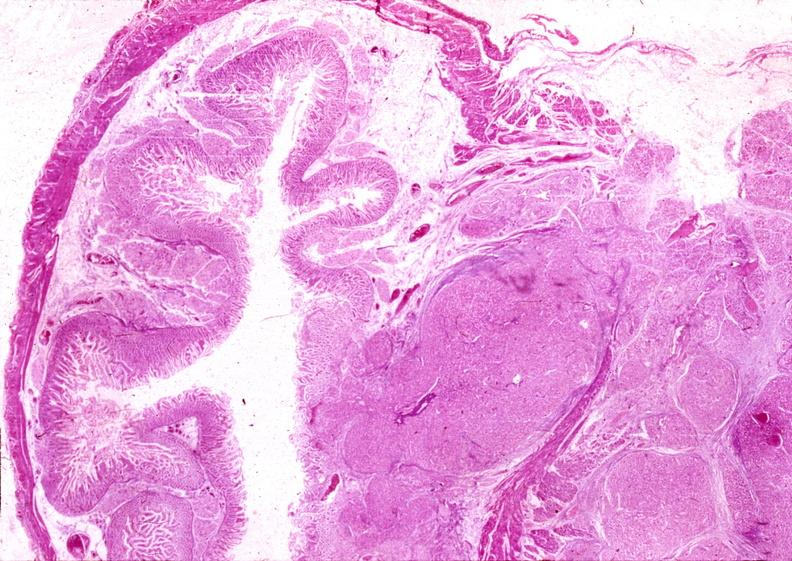does this image show islet cell carcinoma?
Answer the question using a single word or phrase. Yes 